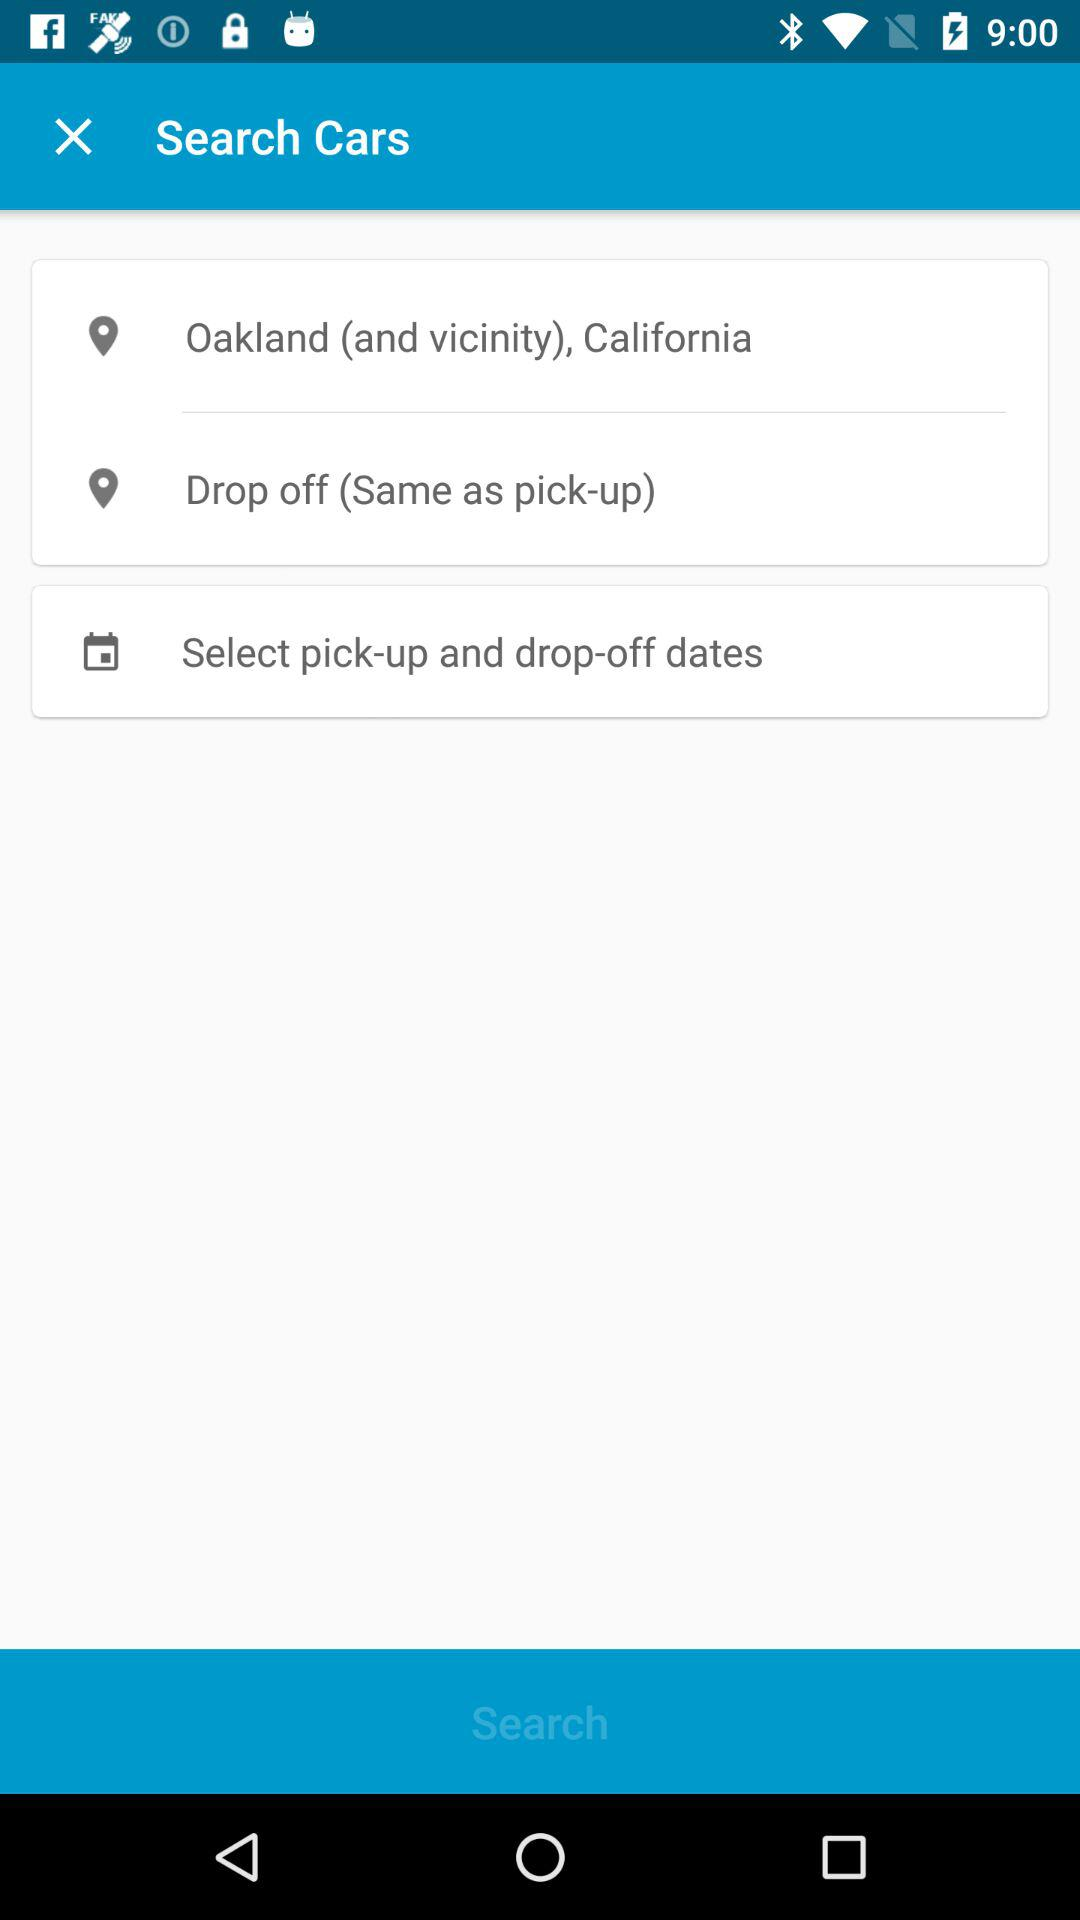What is the pickup location? The pickup location is Oakland (and vicinity), California. 